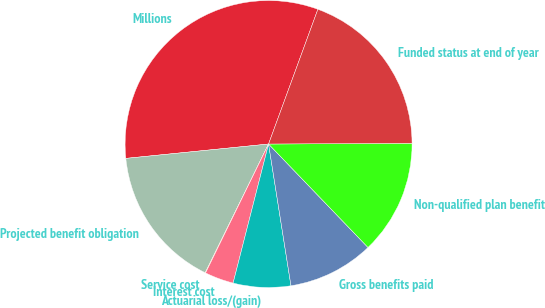Convert chart. <chart><loc_0><loc_0><loc_500><loc_500><pie_chart><fcel>Millions<fcel>Projected benefit obligation<fcel>Service cost<fcel>Interest cost<fcel>Actuarial loss/(gain)<fcel>Gross benefits paid<fcel>Non-qualified plan benefit<fcel>Funded status at end of year<nl><fcel>32.18%<fcel>16.12%<fcel>0.05%<fcel>3.26%<fcel>6.47%<fcel>9.69%<fcel>12.9%<fcel>19.33%<nl></chart> 